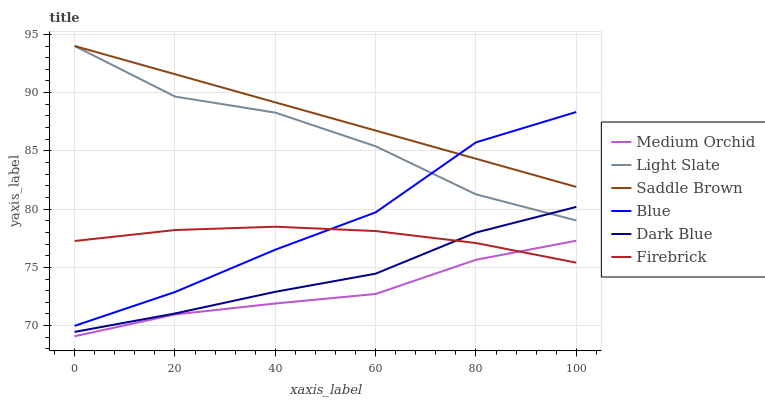Does Medium Orchid have the minimum area under the curve?
Answer yes or no. Yes. Does Saddle Brown have the maximum area under the curve?
Answer yes or no. Yes. Does Light Slate have the minimum area under the curve?
Answer yes or no. No. Does Light Slate have the maximum area under the curve?
Answer yes or no. No. Is Saddle Brown the smoothest?
Answer yes or no. Yes. Is Light Slate the roughest?
Answer yes or no. Yes. Is Firebrick the smoothest?
Answer yes or no. No. Is Firebrick the roughest?
Answer yes or no. No. Does Medium Orchid have the lowest value?
Answer yes or no. Yes. Does Light Slate have the lowest value?
Answer yes or no. No. Does Saddle Brown have the highest value?
Answer yes or no. Yes. Does Firebrick have the highest value?
Answer yes or no. No. Is Firebrick less than Saddle Brown?
Answer yes or no. Yes. Is Saddle Brown greater than Medium Orchid?
Answer yes or no. Yes. Does Blue intersect Firebrick?
Answer yes or no. Yes. Is Blue less than Firebrick?
Answer yes or no. No. Is Blue greater than Firebrick?
Answer yes or no. No. Does Firebrick intersect Saddle Brown?
Answer yes or no. No. 